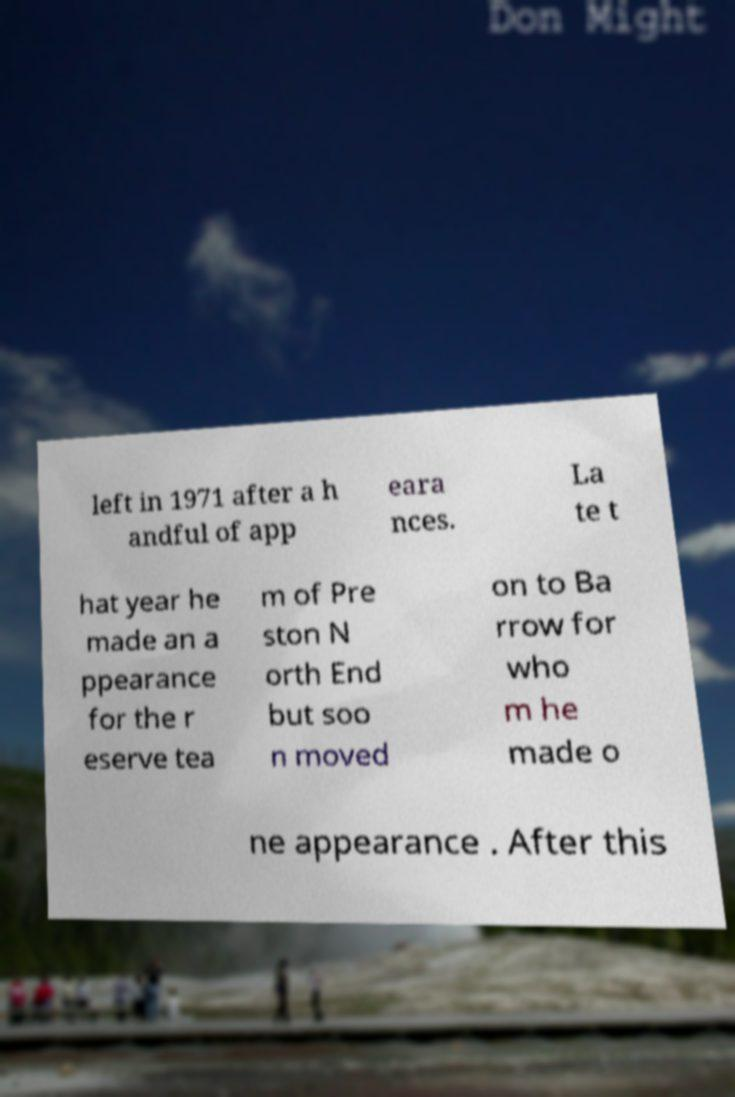I need the written content from this picture converted into text. Can you do that? left in 1971 after a h andful of app eara nces. La te t hat year he made an a ppearance for the r eserve tea m of Pre ston N orth End but soo n moved on to Ba rrow for who m he made o ne appearance . After this 